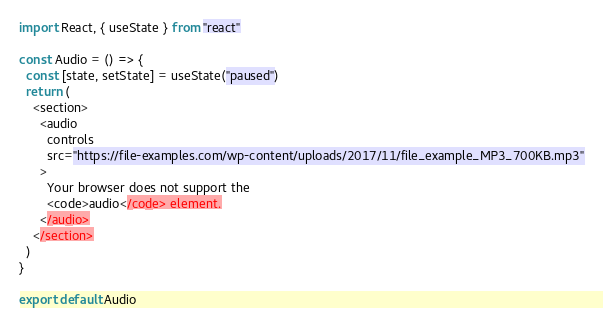<code> <loc_0><loc_0><loc_500><loc_500><_JavaScript_>import React, { useState } from "react"

const Audio = () => {
  const [state, setState] = useState("paused")
  return (
    <section>
      <audio
        controls
        src="https://file-examples.com/wp-content/uploads/2017/11/file_example_MP3_700KB.mp3"
      >
        Your browser does not support the
        <code>audio</code> element.
      </audio>
    </section>
  )
}

export default Audio
</code> 